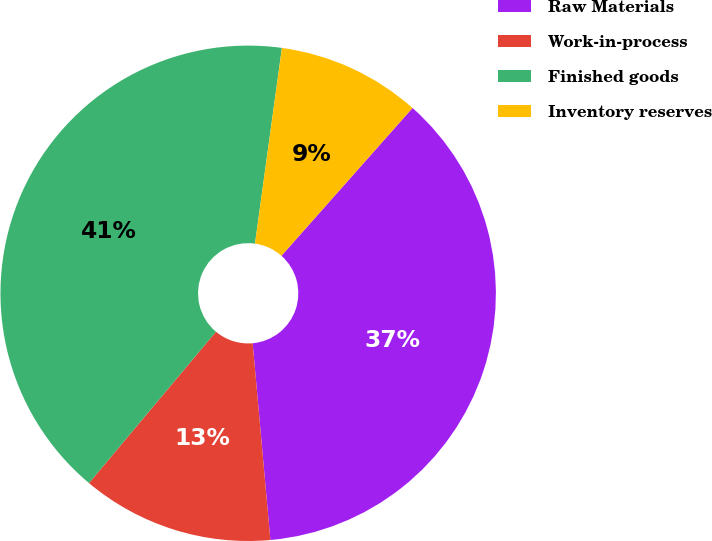<chart> <loc_0><loc_0><loc_500><loc_500><pie_chart><fcel>Raw Materials<fcel>Work-in-process<fcel>Finished goods<fcel>Inventory reserves<nl><fcel>37.03%<fcel>12.54%<fcel>41.07%<fcel>9.37%<nl></chart> 